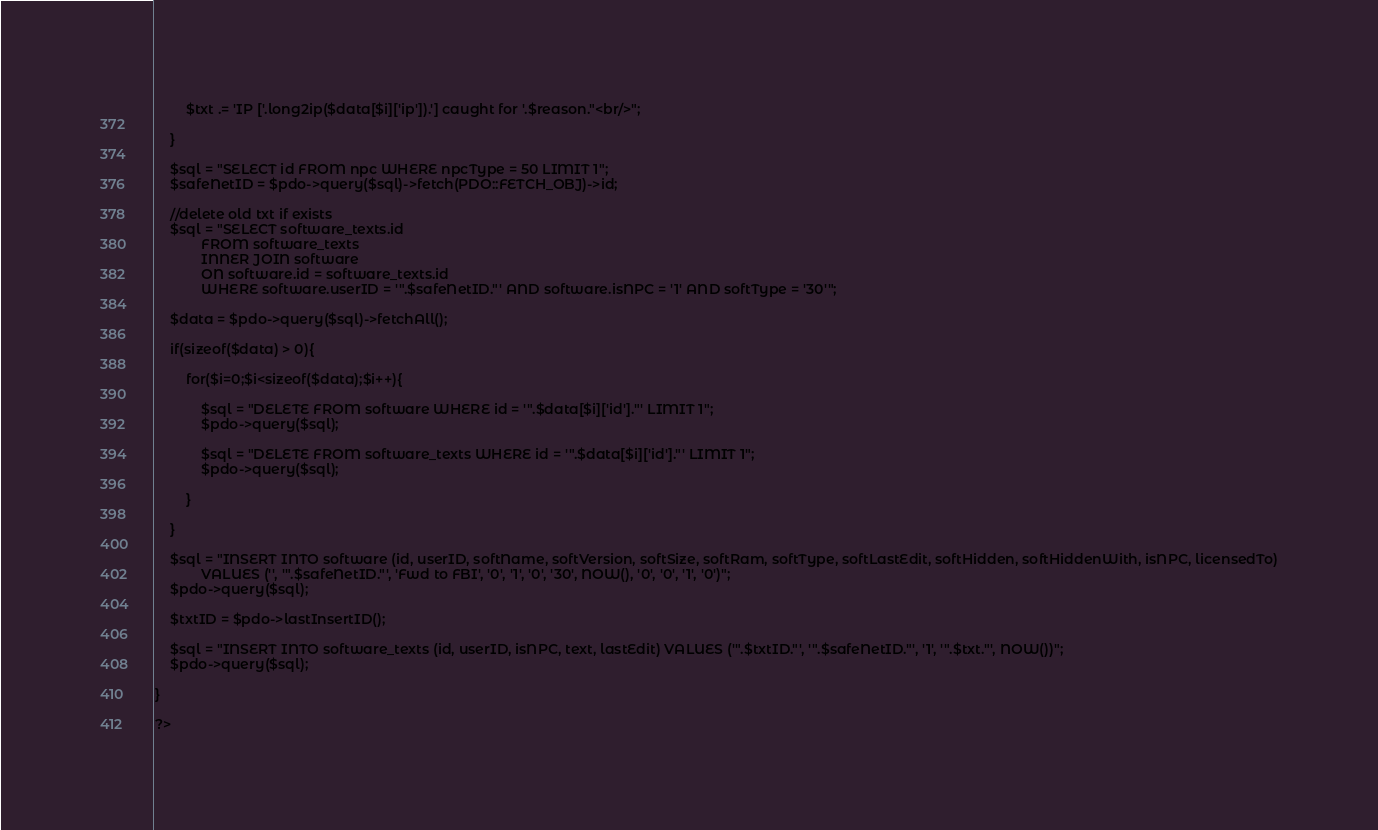<code> <loc_0><loc_0><loc_500><loc_500><_PHP_>
        $txt .= 'IP ['.long2ip($data[$i]['ip']).'] caught for '.$reason."<br/>";

    }

    $sql = "SELECT id FROM npc WHERE npcType = 50 LIMIT 1";
    $safeNetID = $pdo->query($sql)->fetch(PDO::FETCH_OBJ)->id;
    
    //delete old txt if exists
    $sql = "SELECT software_texts.id 
            FROM software_texts
            INNER JOIN software
            ON software.id = software_texts.id
            WHERE software.userID = '".$safeNetID."' AND software.isNPC = '1' AND softType = '30'";

    $data = $pdo->query($sql)->fetchAll();    
    
    if(sizeof($data) > 0){

        for($i=0;$i<sizeof($data);$i++){
            
            $sql = "DELETE FROM software WHERE id = '".$data[$i]['id']."' LIMIT 1";
            $pdo->query($sql);
            
            $sql = "DELETE FROM software_texts WHERE id = '".$data[$i]['id']."' LIMIT 1";
            $pdo->query($sql);
            
        }
        
    }

    $sql = "INSERT INTO software (id, userID, softName, softVersion, softSize, softRam, softType, softLastEdit, softHidden, softHiddenWith, isNPC, licensedTo)
            VALUES ('', '".$safeNetID."', 'Fwd to FBI', '0', '1', '0', '30', NOW(), '0', '0', '1', '0')";
    $pdo->query($sql);

    $txtID = $pdo->lastInsertID();

    $sql = "INSERT INTO software_texts (id, userID, isNPC, text, lastEdit) VALUES ('".$txtID."', '".$safeNetID."', '1', '".$txt."', NOW())";
    $pdo->query($sql);    
    
}

?>
</code> 